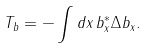Convert formula to latex. <formula><loc_0><loc_0><loc_500><loc_500>T _ { b } & = - \int d x \, b _ { x } ^ { * } \Delta b _ { x } .</formula> 